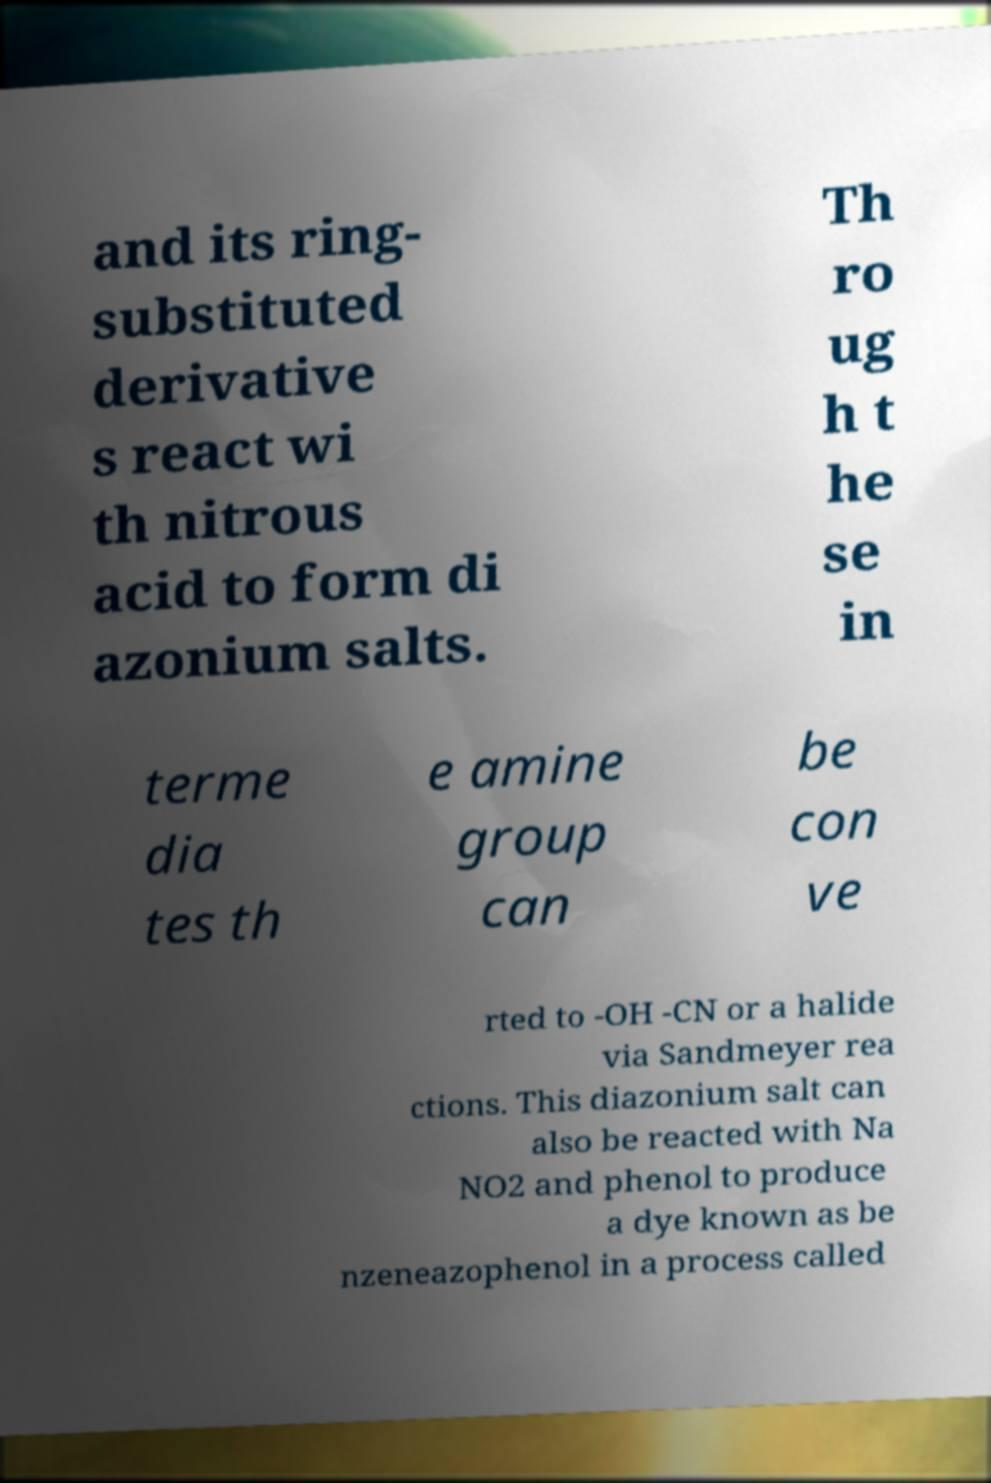Could you extract and type out the text from this image? and its ring- substituted derivative s react wi th nitrous acid to form di azonium salts. Th ro ug h t he se in terme dia tes th e amine group can be con ve rted to -OH -CN or a halide via Sandmeyer rea ctions. This diazonium salt can also be reacted with Na NO2 and phenol to produce a dye known as be nzeneazophenol in a process called 